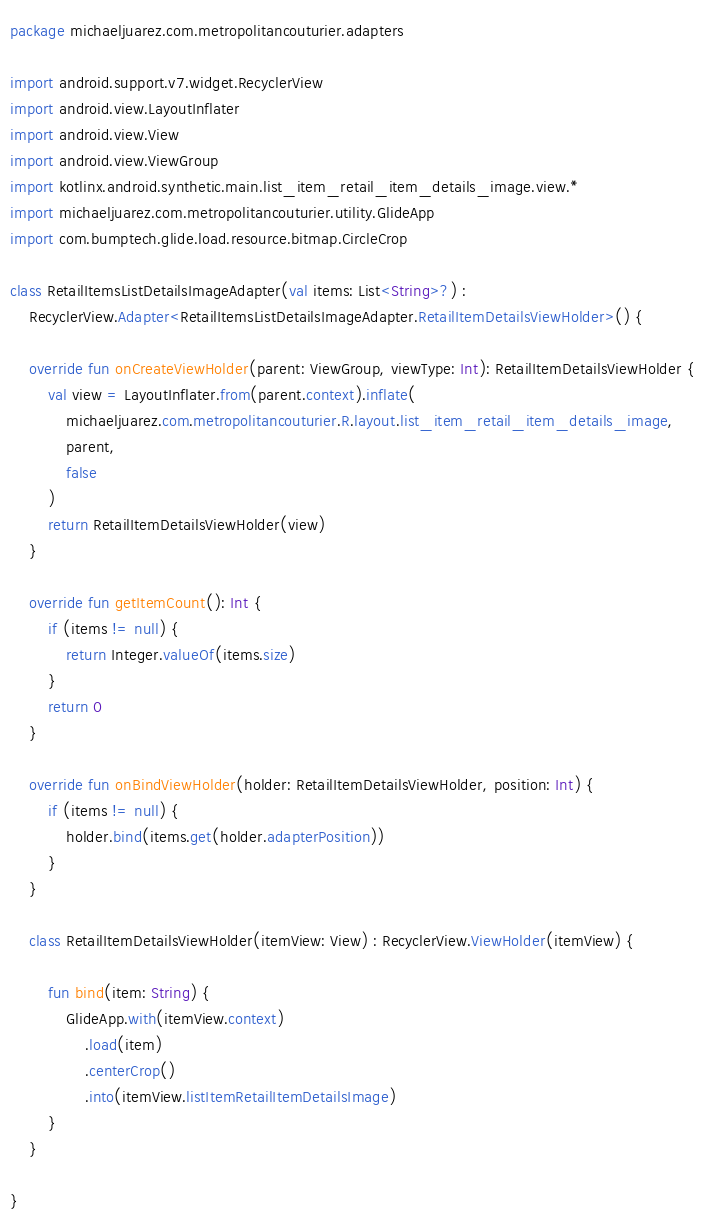<code> <loc_0><loc_0><loc_500><loc_500><_Kotlin_>package michaeljuarez.com.metropolitancouturier.adapters

import android.support.v7.widget.RecyclerView
import android.view.LayoutInflater
import android.view.View
import android.view.ViewGroup
import kotlinx.android.synthetic.main.list_item_retail_item_details_image.view.*
import michaeljuarez.com.metropolitancouturier.utility.GlideApp
import com.bumptech.glide.load.resource.bitmap.CircleCrop

class RetailItemsListDetailsImageAdapter(val items: List<String>?) :
    RecyclerView.Adapter<RetailItemsListDetailsImageAdapter.RetailItemDetailsViewHolder>() {

    override fun onCreateViewHolder(parent: ViewGroup, viewType: Int): RetailItemDetailsViewHolder {
        val view = LayoutInflater.from(parent.context).inflate(
            michaeljuarez.com.metropolitancouturier.R.layout.list_item_retail_item_details_image,
            parent,
            false
        )
        return RetailItemDetailsViewHolder(view)
    }

    override fun getItemCount(): Int {
        if (items != null) {
            return Integer.valueOf(items.size)
        }
        return 0
    }

    override fun onBindViewHolder(holder: RetailItemDetailsViewHolder, position: Int) {
        if (items != null) {
            holder.bind(items.get(holder.adapterPosition))
        }
    }

    class RetailItemDetailsViewHolder(itemView: View) : RecyclerView.ViewHolder(itemView) {

        fun bind(item: String) {
            GlideApp.with(itemView.context)
                .load(item)
                .centerCrop()
                .into(itemView.listItemRetailItemDetailsImage)
        }
    }

}</code> 